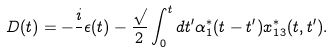Convert formula to latex. <formula><loc_0><loc_0><loc_500><loc_500>D ( t ) = - \frac { i } { } \epsilon ( t ) - \frac { \sqrt { } } { 2 } \int _ { 0 } ^ { t } d t ^ { \prime } \alpha ^ { * } _ { 1 } ( t - t ^ { \prime } ) x ^ { * } _ { 1 3 } ( t , t ^ { \prime } ) .</formula> 